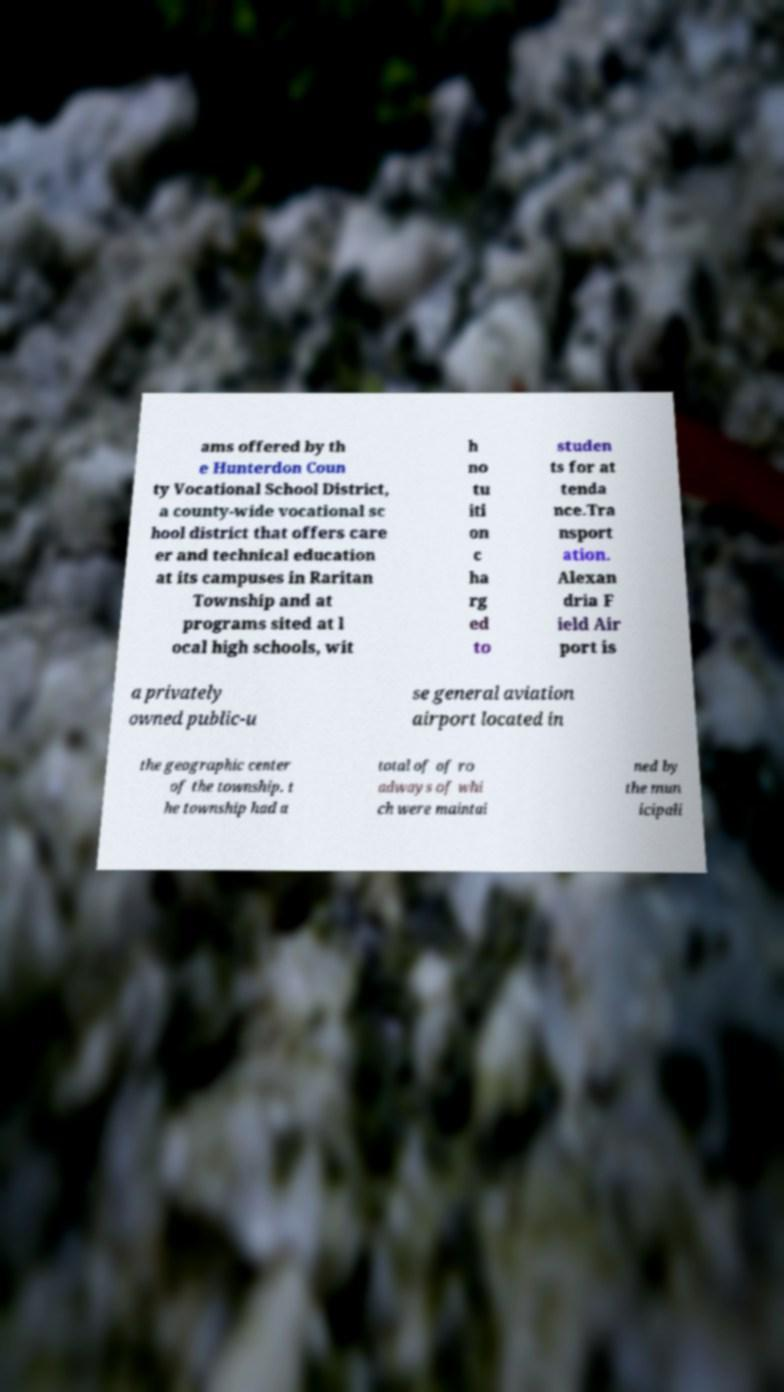Can you accurately transcribe the text from the provided image for me? ams offered by th e Hunterdon Coun ty Vocational School District, a county-wide vocational sc hool district that offers care er and technical education at its campuses in Raritan Township and at programs sited at l ocal high schools, wit h no tu iti on c ha rg ed to studen ts for at tenda nce.Tra nsport ation. Alexan dria F ield Air port is a privately owned public-u se general aviation airport located in the geographic center of the township. t he township had a total of of ro adways of whi ch were maintai ned by the mun icipali 